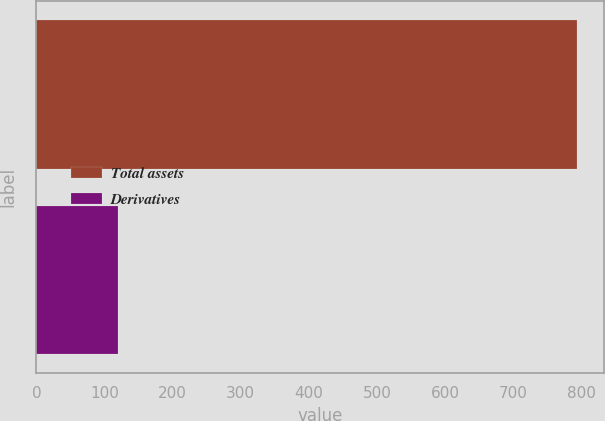Convert chart. <chart><loc_0><loc_0><loc_500><loc_500><bar_chart><fcel>Total assets<fcel>Derivatives<nl><fcel>793<fcel>120<nl></chart> 